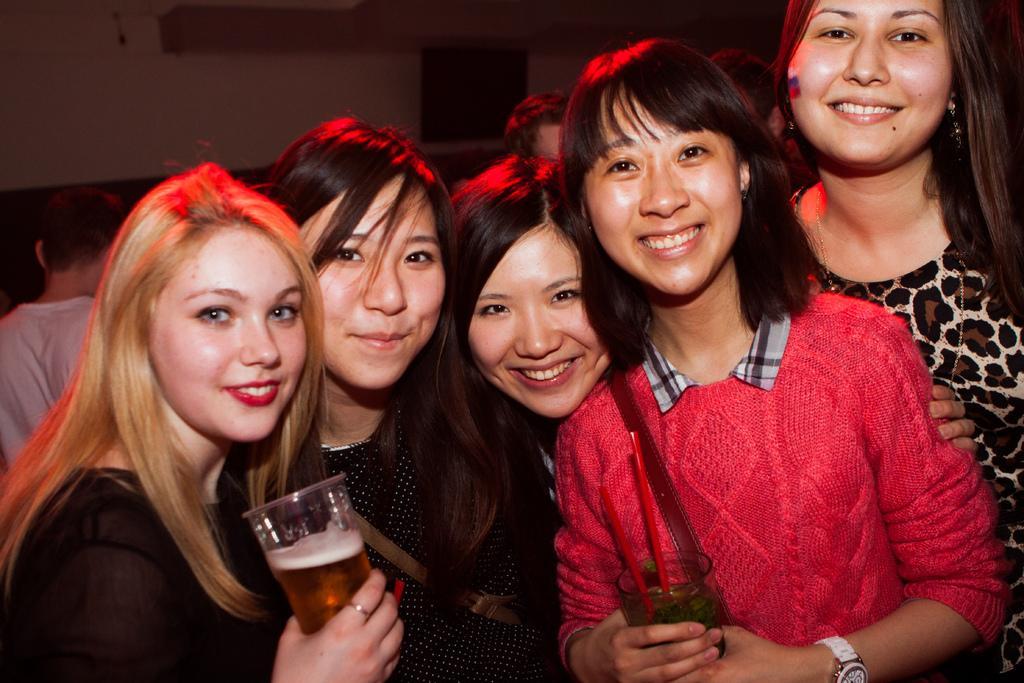In one or two sentences, can you explain what this image depicts? In the image we can see there are women who are standing and they are smiling and woman in the corner is holding a wine glass in her hand. 